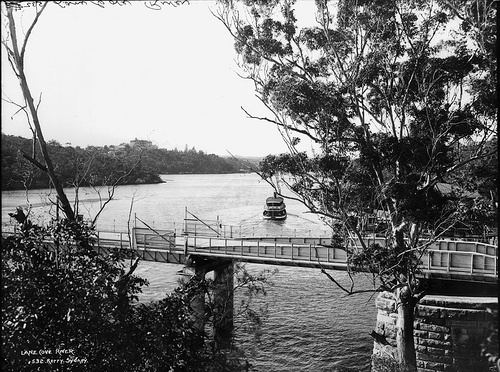Describe the objects in this image and their specific colors. I can see a boat in black, gray, darkgray, and gainsboro tones in this image. 